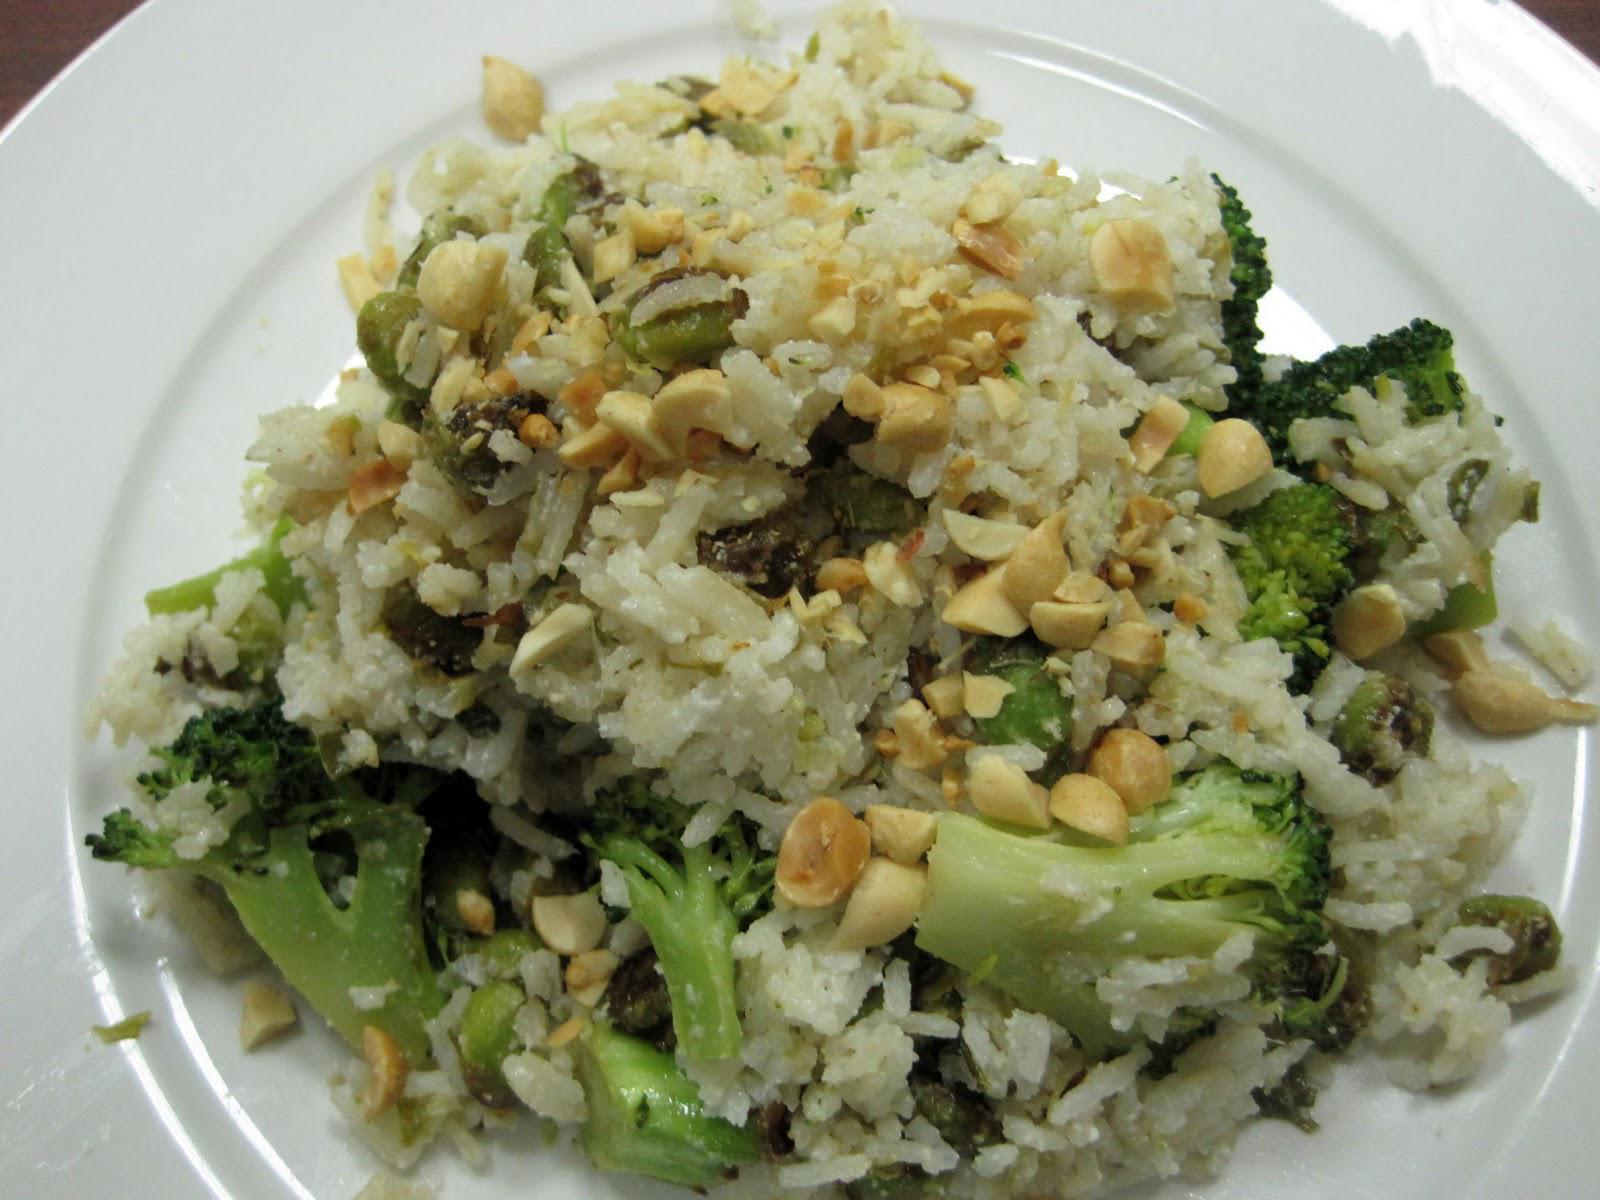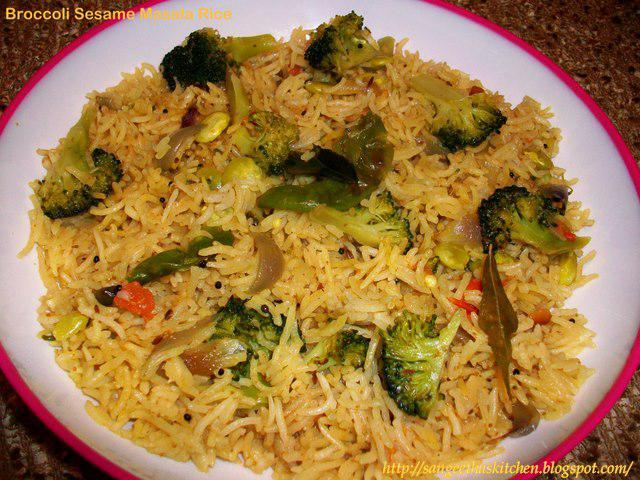The first image is the image on the left, the second image is the image on the right. Examine the images to the left and right. Is the description "the rice on the left image is on a white plate" accurate? Answer yes or no. Yes. 